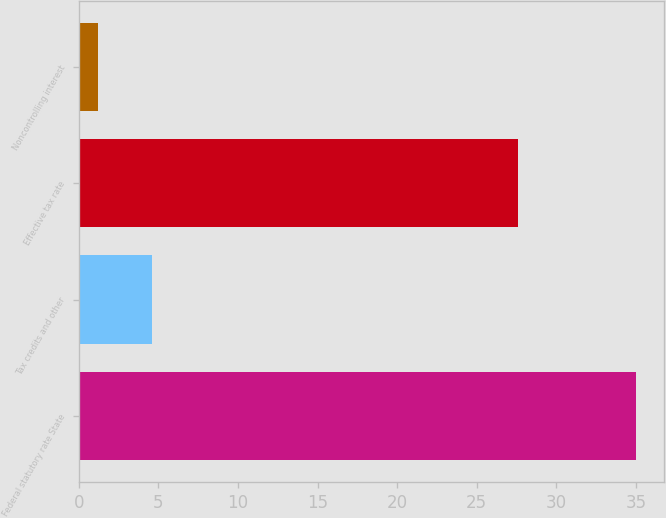Convert chart to OTSL. <chart><loc_0><loc_0><loc_500><loc_500><bar_chart><fcel>Federal statutory rate State<fcel>Tax credits and other<fcel>Effective tax rate<fcel>Noncontrolling interest<nl><fcel>35<fcel>4.58<fcel>27.6<fcel>1.2<nl></chart> 